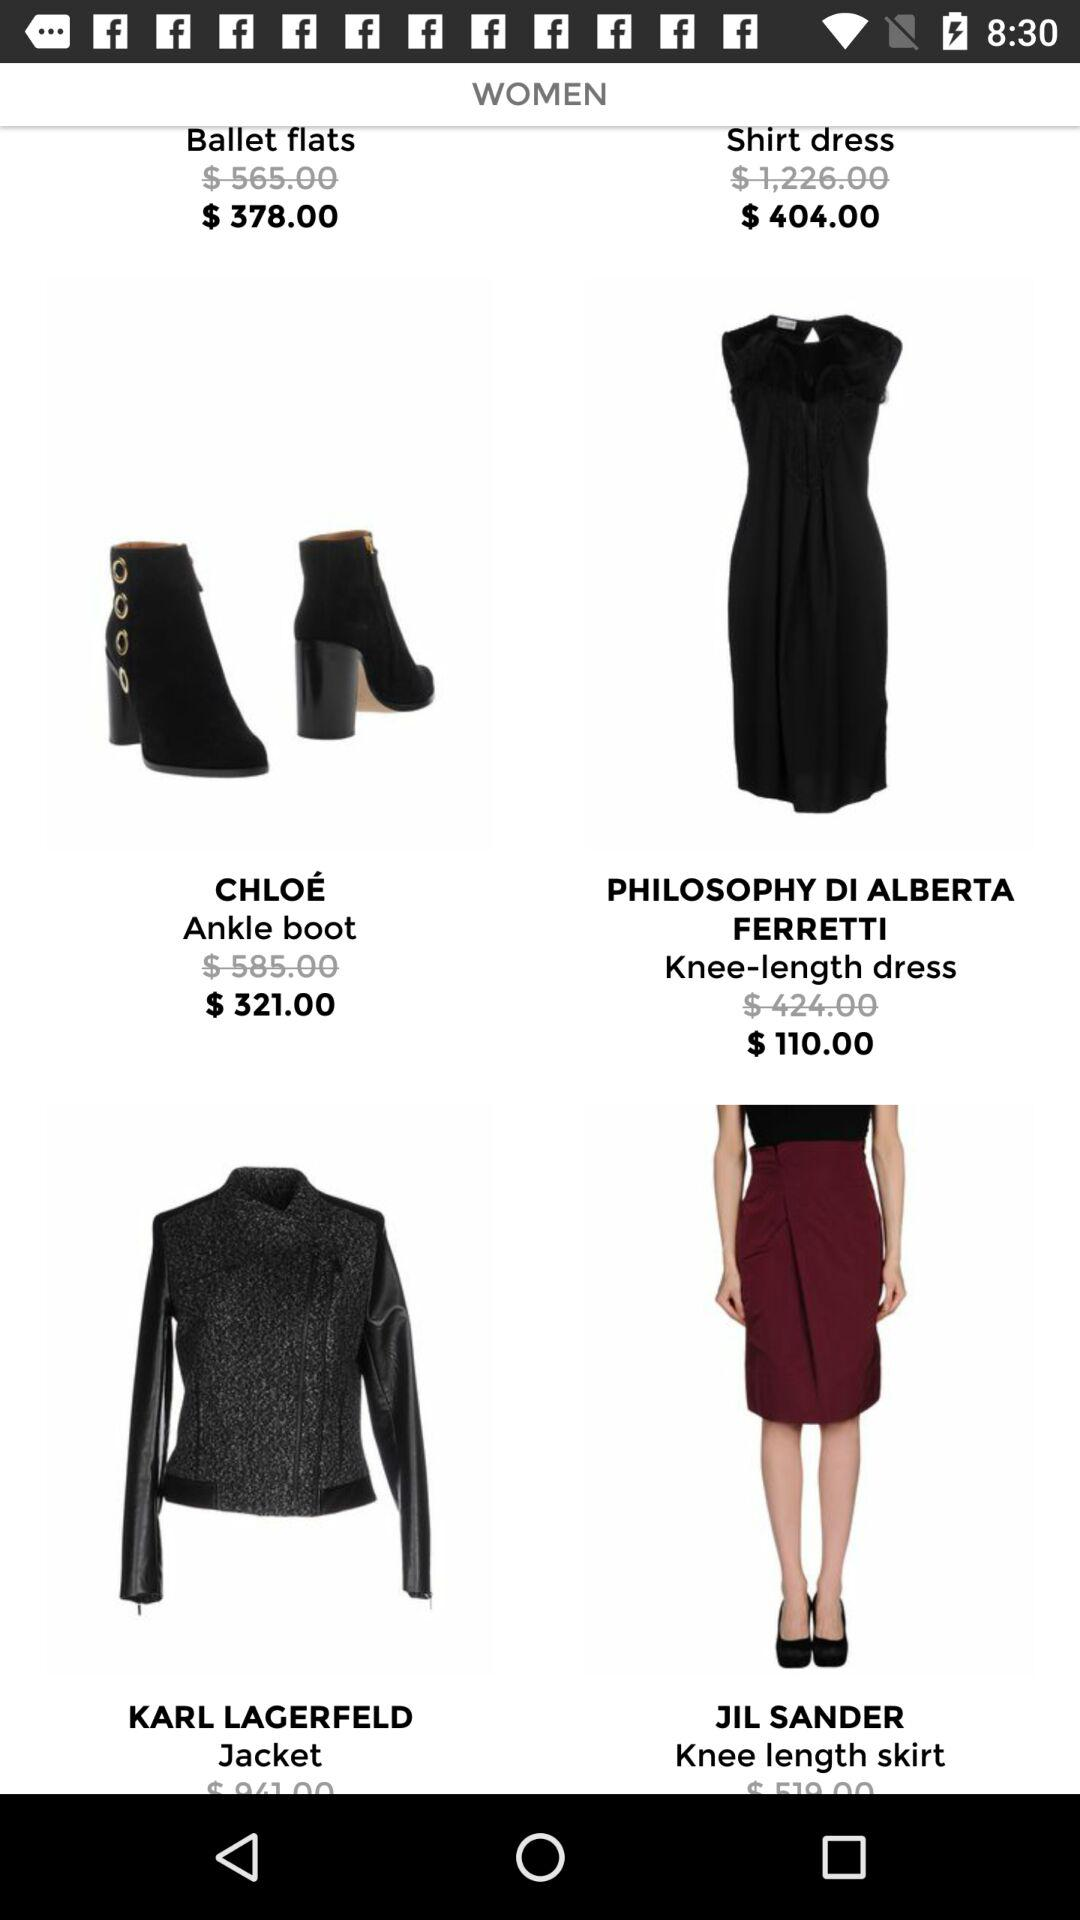What was the original cost of ankle boots? The original cost of ankle boots was $585.00. 